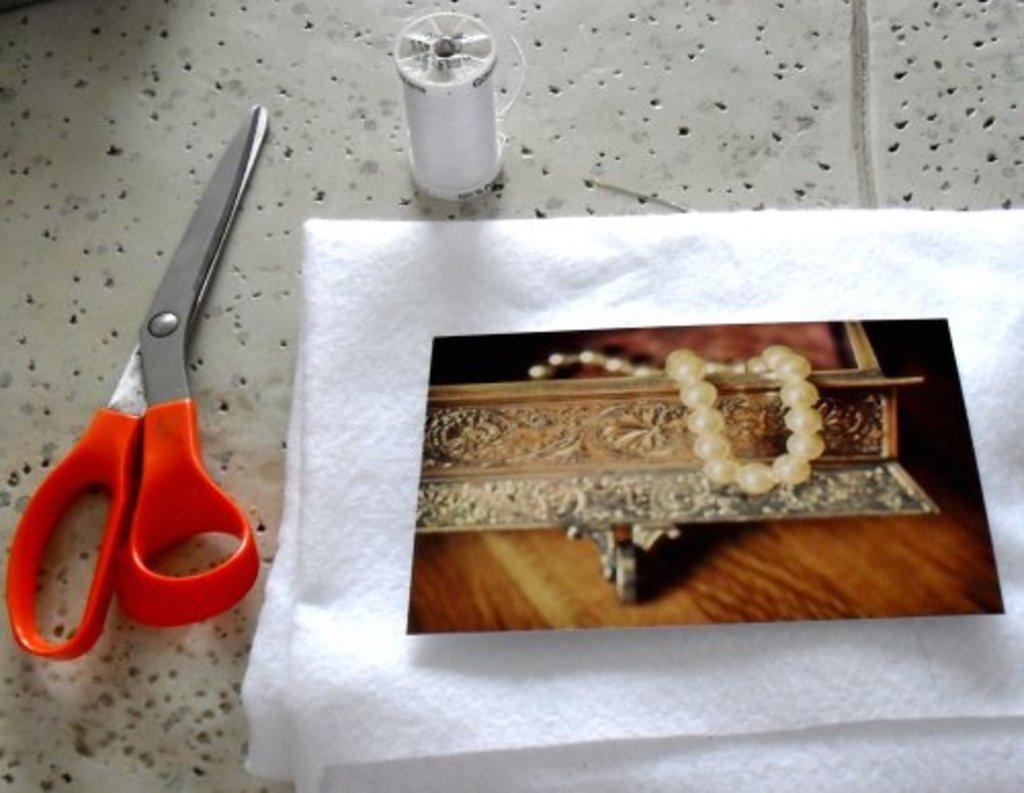In one or two sentences, can you explain what this image depicts? On the table I can see the scissor, tissue paper, photo and tread. In that photo I can see the book and wooden table. 